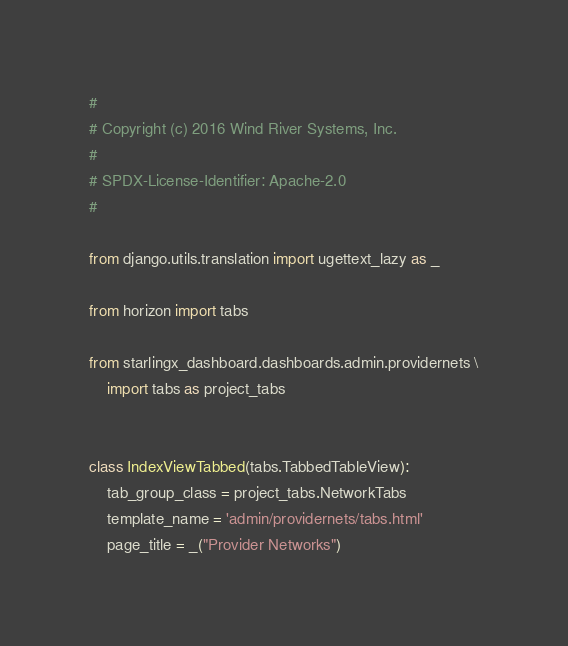Convert code to text. <code><loc_0><loc_0><loc_500><loc_500><_Python_>#
# Copyright (c) 2016 Wind River Systems, Inc.
#
# SPDX-License-Identifier: Apache-2.0
#

from django.utils.translation import ugettext_lazy as _

from horizon import tabs

from starlingx_dashboard.dashboards.admin.providernets \
    import tabs as project_tabs


class IndexViewTabbed(tabs.TabbedTableView):
    tab_group_class = project_tabs.NetworkTabs
    template_name = 'admin/providernets/tabs.html'
    page_title = _("Provider Networks")
</code> 